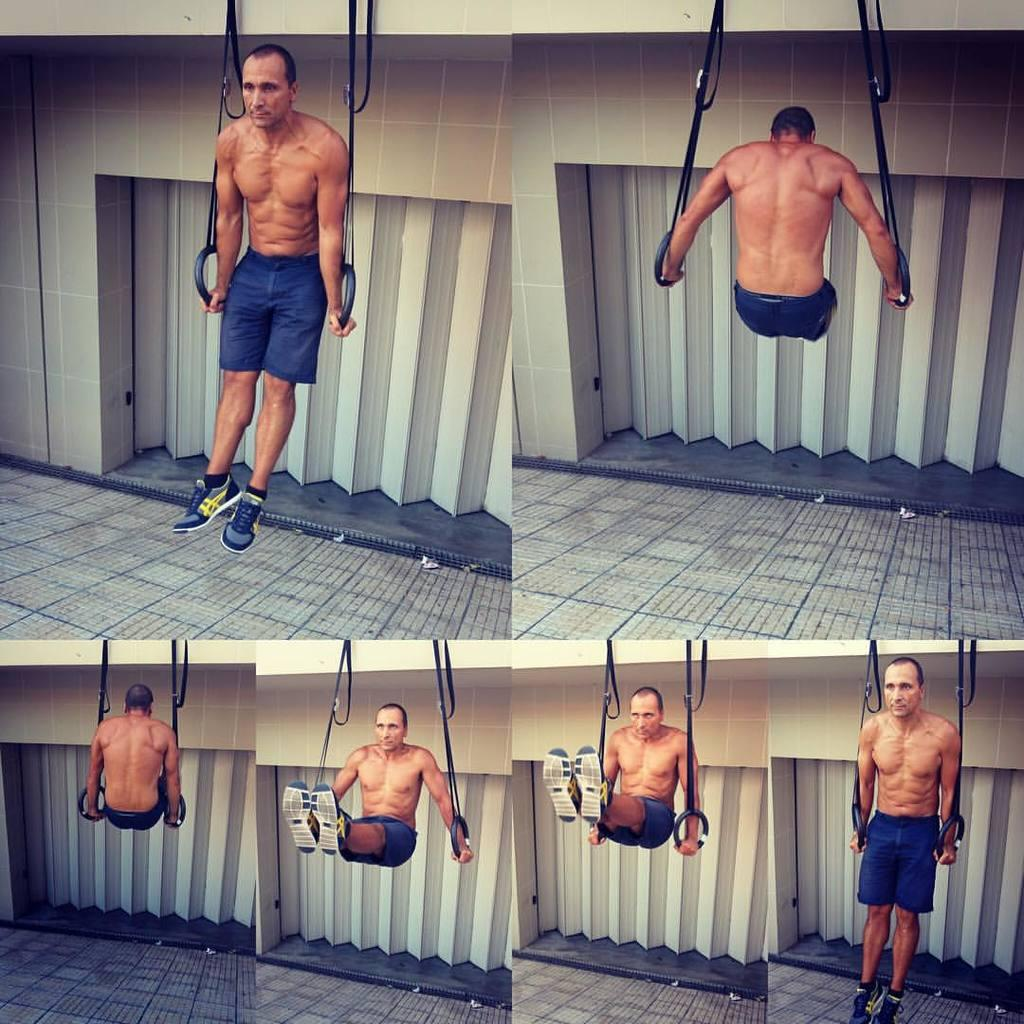What is the main subject of the image? The image is a collection of collages. What activity is the man doing in each collage? In each collage, there is a man doing pull up exercises. What can be seen in the background of the collages? There is a wall visible in the background of the collages. How many pets are visible in the image? There are no pets present in the image; it features a collection of collages with a man doing pull up exercises and a wall in the background. What time is displayed on the clock in the image? There is no clock present in the image. 